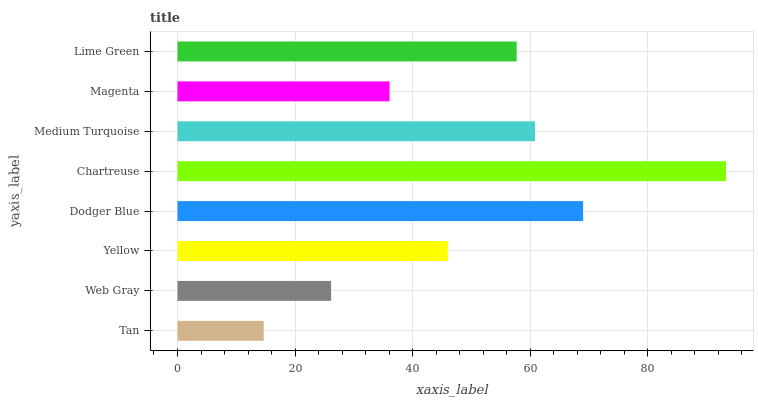Is Tan the minimum?
Answer yes or no. Yes. Is Chartreuse the maximum?
Answer yes or no. Yes. Is Web Gray the minimum?
Answer yes or no. No. Is Web Gray the maximum?
Answer yes or no. No. Is Web Gray greater than Tan?
Answer yes or no. Yes. Is Tan less than Web Gray?
Answer yes or no. Yes. Is Tan greater than Web Gray?
Answer yes or no. No. Is Web Gray less than Tan?
Answer yes or no. No. Is Lime Green the high median?
Answer yes or no. Yes. Is Yellow the low median?
Answer yes or no. Yes. Is Medium Turquoise the high median?
Answer yes or no. No. Is Tan the low median?
Answer yes or no. No. 